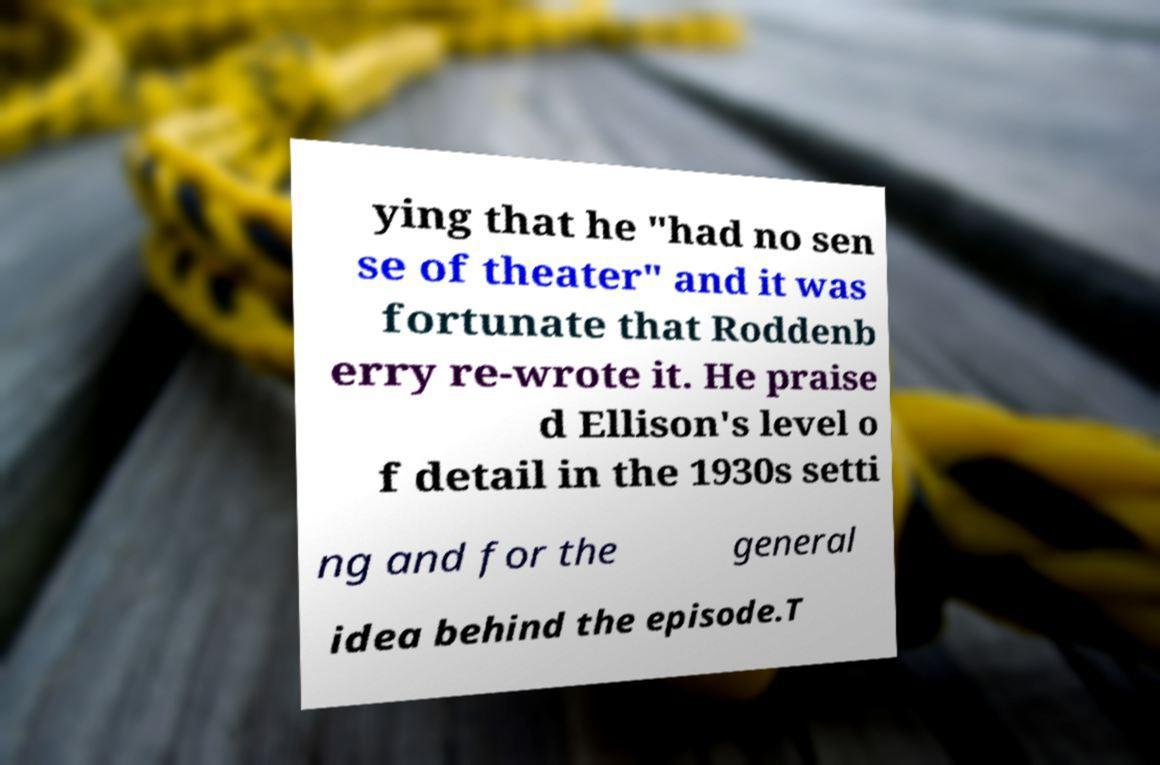Could you extract and type out the text from this image? ying that he "had no sen se of theater" and it was fortunate that Roddenb erry re-wrote it. He praise d Ellison's level o f detail in the 1930s setti ng and for the general idea behind the episode.T 